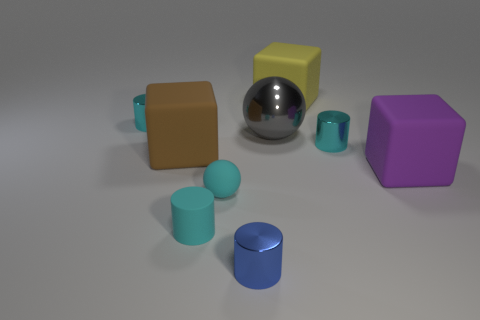What are the possible materials of these objects, based on their appearance? The objects seem to be made from different materials: the silver object looks metallic due to its high reflectivity; the yellow and brown cubes appear matte, possibly resembling plastic or painted wood; and the teal cylinders could be ceramic or powder-coated metal, given their slight sheen. 